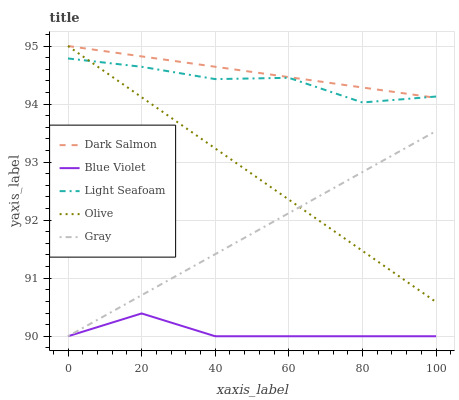Does Gray have the minimum area under the curve?
Answer yes or no. No. Does Gray have the maximum area under the curve?
Answer yes or no. No. Is Light Seafoam the smoothest?
Answer yes or no. No. Is Gray the roughest?
Answer yes or no. No. Does Light Seafoam have the lowest value?
Answer yes or no. No. Does Gray have the highest value?
Answer yes or no. No. Is Gray less than Dark Salmon?
Answer yes or no. Yes. Is Light Seafoam greater than Blue Violet?
Answer yes or no. Yes. Does Gray intersect Dark Salmon?
Answer yes or no. No. 